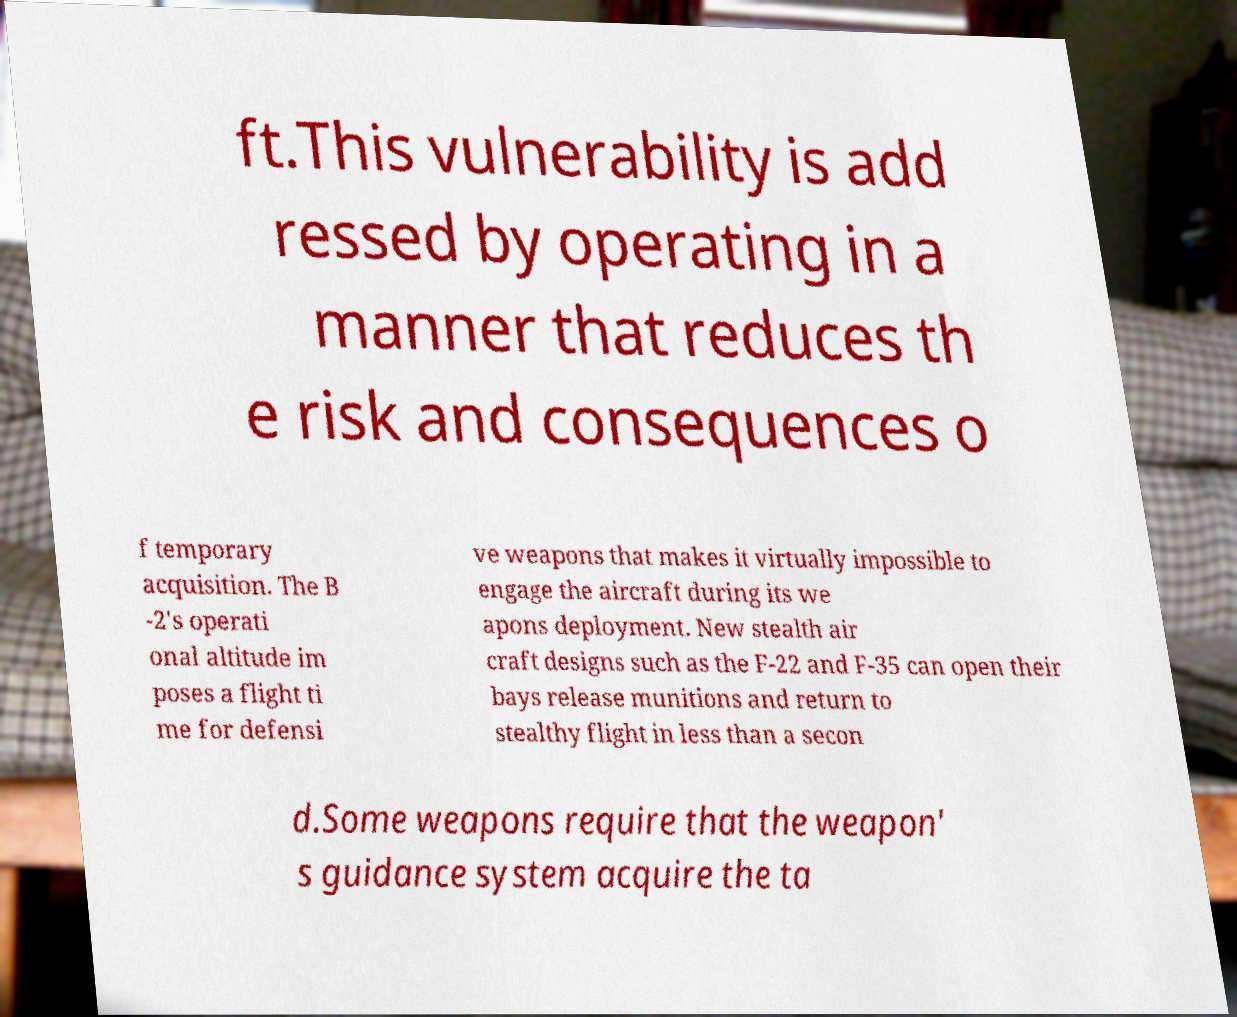Please read and relay the text visible in this image. What does it say? ft.This vulnerability is add ressed by operating in a manner that reduces th e risk and consequences o f temporary acquisition. The B -2's operati onal altitude im poses a flight ti me for defensi ve weapons that makes it virtually impossible to engage the aircraft during its we apons deployment. New stealth air craft designs such as the F-22 and F-35 can open their bays release munitions and return to stealthy flight in less than a secon d.Some weapons require that the weapon' s guidance system acquire the ta 